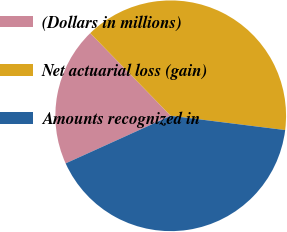Convert chart to OTSL. <chart><loc_0><loc_0><loc_500><loc_500><pie_chart><fcel>(Dollars in millions)<fcel>Net actuarial loss (gain)<fcel>Amounts recognized in<nl><fcel>19.48%<fcel>39.27%<fcel>41.25%<nl></chart> 